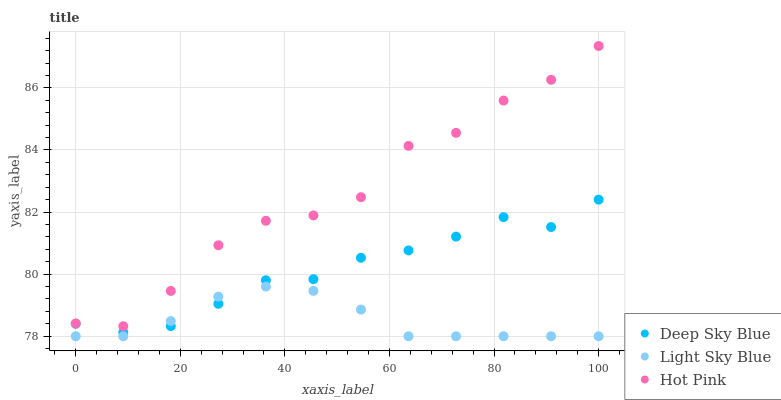Does Light Sky Blue have the minimum area under the curve?
Answer yes or no. Yes. Does Hot Pink have the maximum area under the curve?
Answer yes or no. Yes. Does Deep Sky Blue have the minimum area under the curve?
Answer yes or no. No. Does Deep Sky Blue have the maximum area under the curve?
Answer yes or no. No. Is Light Sky Blue the smoothest?
Answer yes or no. Yes. Is Hot Pink the roughest?
Answer yes or no. Yes. Is Deep Sky Blue the smoothest?
Answer yes or no. No. Is Deep Sky Blue the roughest?
Answer yes or no. No. Does Light Sky Blue have the lowest value?
Answer yes or no. Yes. Does Deep Sky Blue have the lowest value?
Answer yes or no. No. Does Hot Pink have the highest value?
Answer yes or no. Yes. Does Deep Sky Blue have the highest value?
Answer yes or no. No. Is Light Sky Blue less than Hot Pink?
Answer yes or no. Yes. Is Hot Pink greater than Light Sky Blue?
Answer yes or no. Yes. Does Deep Sky Blue intersect Light Sky Blue?
Answer yes or no. Yes. Is Deep Sky Blue less than Light Sky Blue?
Answer yes or no. No. Is Deep Sky Blue greater than Light Sky Blue?
Answer yes or no. No. Does Light Sky Blue intersect Hot Pink?
Answer yes or no. No. 